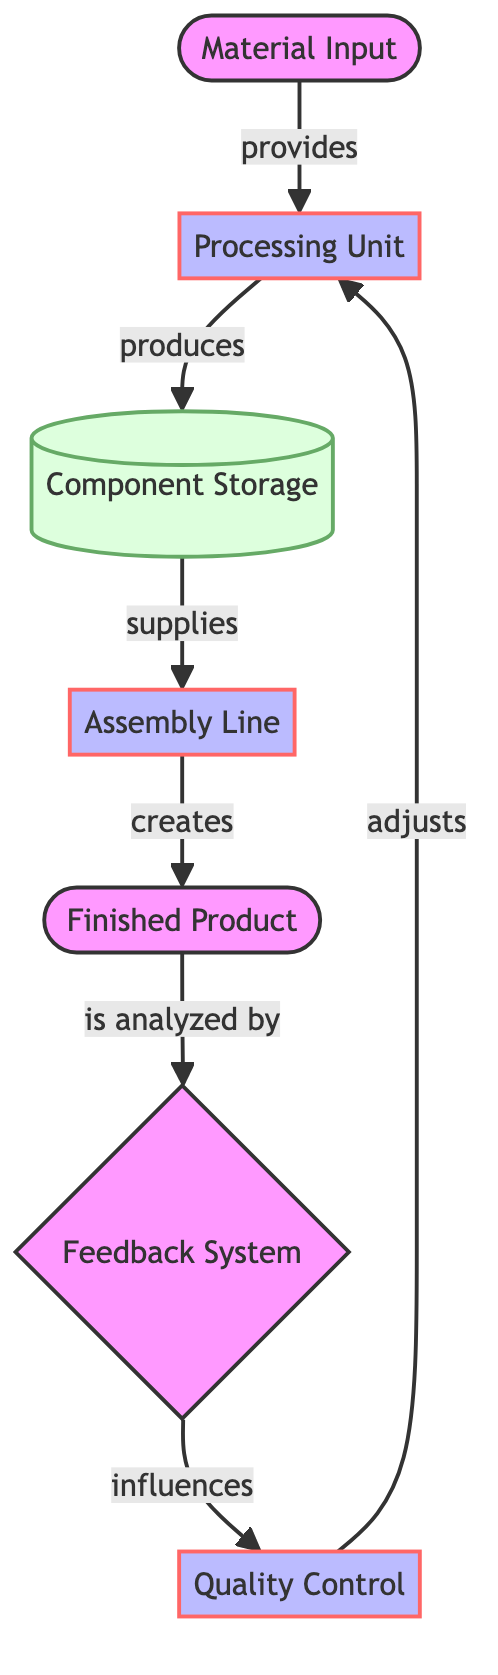What is the first node in the flow diagram? The diagram indicates that the first node where the process begins is "Material Input." This node represents the point at which raw materials are introduced into the system.
Answer: Material Input How many nodes are present in the diagram? Counting all unique nodes listed in the data, there are 7 nodes: Material Input, Processing Unit, Component Storage, Assembly Line, Feedback System, Quality Control, and Finished Product.
Answer: 7 What does the Processing Unit produce? The arrow labeled "produces" leading from "Processing Unit" points to "Component Storage." Thus, the Processing Unit produces components that are stored in the Component Storage.
Answer: Component Storage Which node influences the Quality Control? According to the diagram, the "Feedback System" has an arrow directed towards "Quality Control," indicating that it has a role in influencing decisions or actions taken in Quality Control.
Answer: Feedback System What is the final output of the mechanical system? The final node indicating the output of the entire processing flow is labeled "Finished Product," which is the end result of the assembly process.
Answer: Finished Product What feedback mechanism is utilized after the Finished Product is created? The diagram indicates that the Finished Product is analyzed by the Feedback System, establishing a feedback mechanism that affects subsequent processes.
Answer: Feedback System How does Quality Control affect the Processing Unit? There is an arrow from Quality Control towards Processing Unit labeled "adjusts," demonstrating that Quality Control can modify or influence the operations of the Processing Unit based on inspection results.
Answer: adjusts What is the relationship between Component Storage and Assembly Line? The diagram shows that the relationship is defined by the edge labeled "supplies," meaning that the Component Storage supplies components to the Assembly Line for further processing.
Answer: supplies Which part of the system checks the quality of products? The node labeled "Quality Control" serves the function of checking or inspecting the quality of the products before they can proceed in the flow, as indicated by its placement within the processing sequence.
Answer: Quality Control 